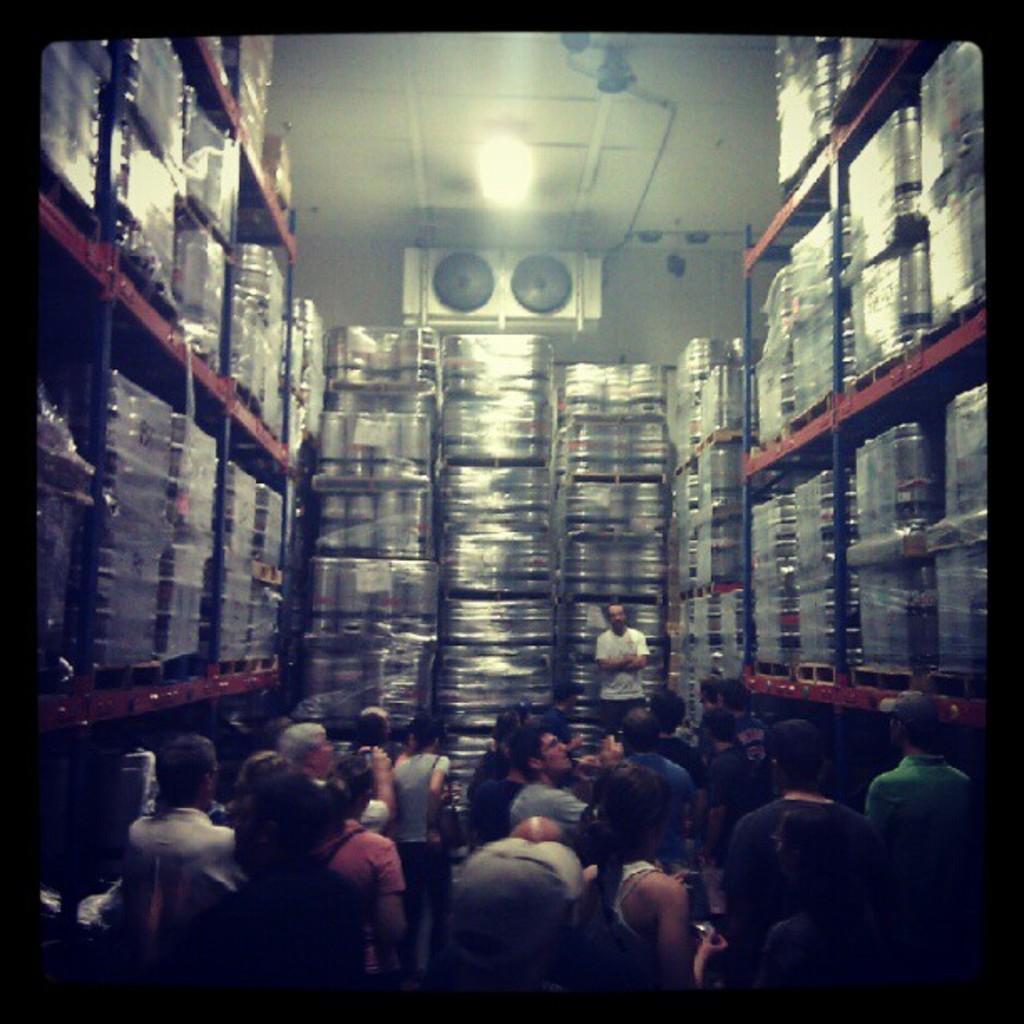Please provide a concise description of this image. In this image we can see some steel objects in the racks. At the bottom of the image there are some persons. At the top of the image there is the ceiling, lights and other objects. 